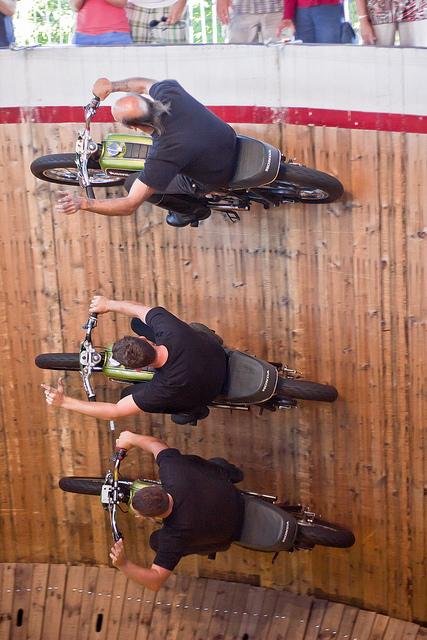Who is the oldest of the three men?
Give a very brief answer. On top with balding hair. Are these men on a vertical or horizontal surface?
Short answer required. Vertical. What type of vehicle are the men on?
Quick response, please. Motorcycles. 